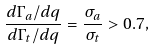Convert formula to latex. <formula><loc_0><loc_0><loc_500><loc_500>\frac { d \Gamma _ { a } / d q } { d \Gamma _ { t } / d q } = \frac { \sigma _ { a } } { \sigma _ { t } } > 0 . 7 ,</formula> 